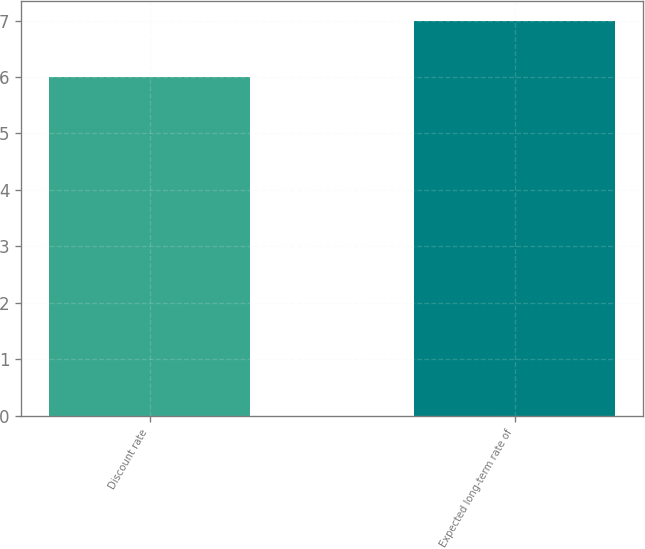<chart> <loc_0><loc_0><loc_500><loc_500><bar_chart><fcel>Discount rate<fcel>Expected long-term rate of<nl><fcel>6<fcel>7<nl></chart> 